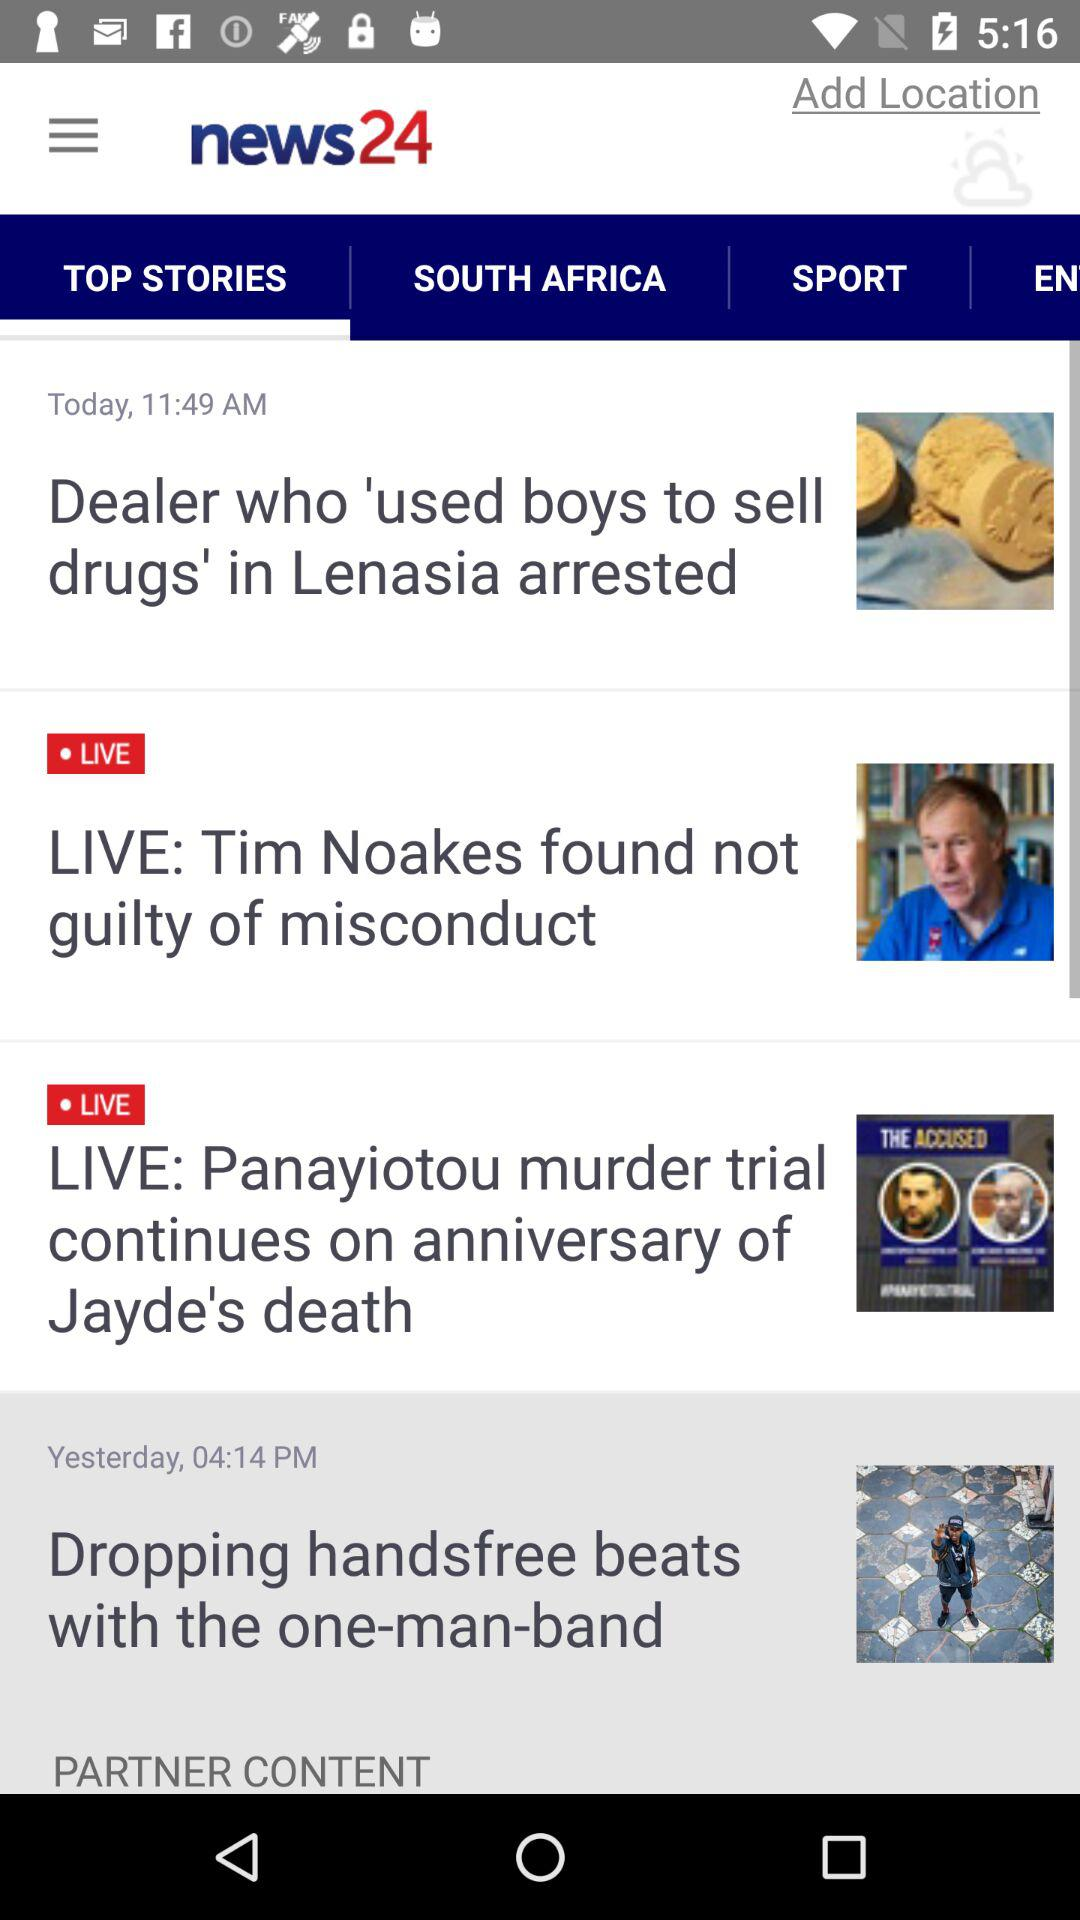How many stories are there on this screen?
Answer the question using a single word or phrase. 4 